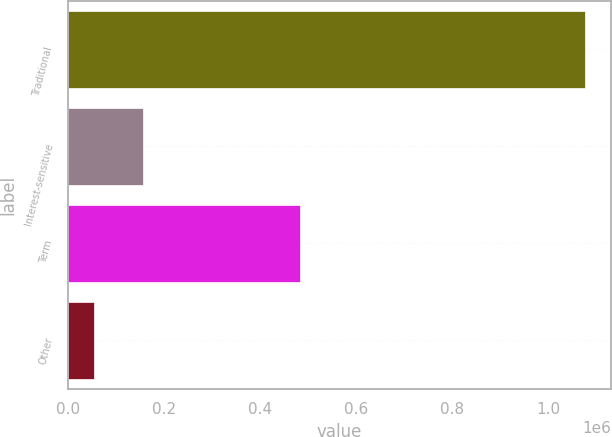Convert chart. <chart><loc_0><loc_0><loc_500><loc_500><bar_chart><fcel>Traditional<fcel>Interest-sensitive<fcel>Term<fcel>Other<nl><fcel>1.07735e+06<fcel>156120<fcel>483064<fcel>53762<nl></chart> 